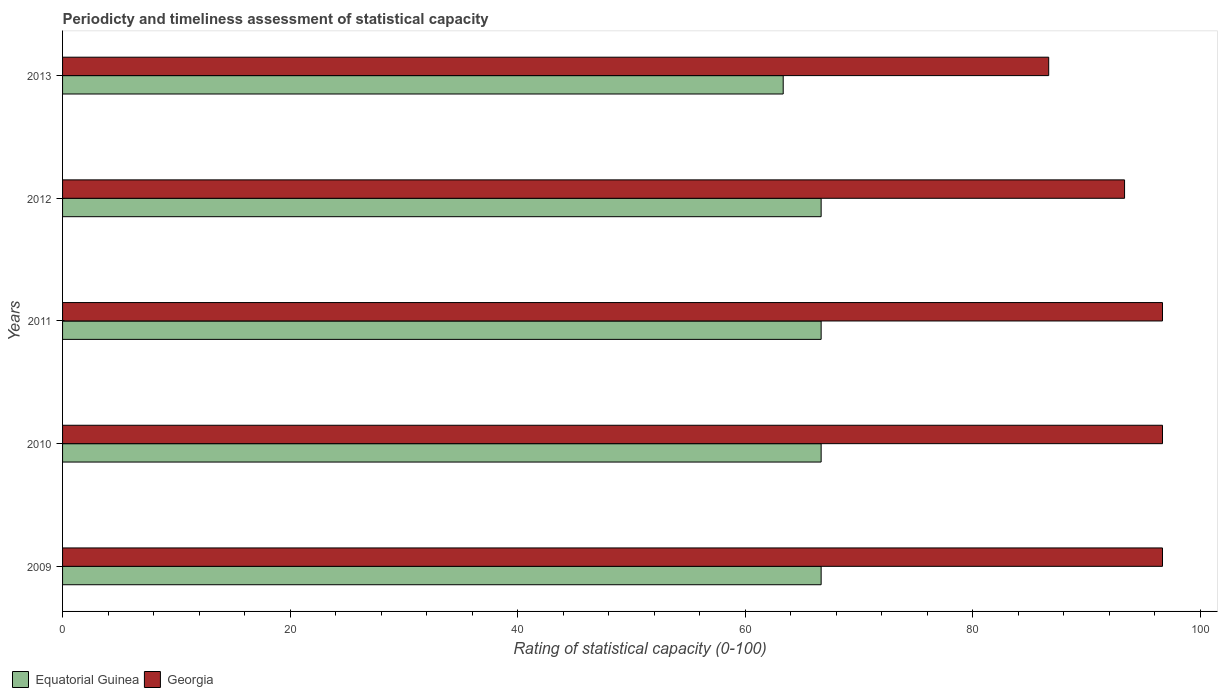Are the number of bars on each tick of the Y-axis equal?
Offer a terse response. Yes. What is the rating of statistical capacity in Georgia in 2013?
Provide a succinct answer. 86.67. Across all years, what is the maximum rating of statistical capacity in Equatorial Guinea?
Provide a short and direct response. 66.67. Across all years, what is the minimum rating of statistical capacity in Georgia?
Offer a very short reply. 86.67. In which year was the rating of statistical capacity in Equatorial Guinea maximum?
Your answer should be compact. 2009. In which year was the rating of statistical capacity in Equatorial Guinea minimum?
Your answer should be very brief. 2013. What is the total rating of statistical capacity in Equatorial Guinea in the graph?
Your answer should be compact. 330. What is the difference between the rating of statistical capacity in Equatorial Guinea in 2011 and that in 2012?
Make the answer very short. 0. What is the difference between the rating of statistical capacity in Georgia in 2010 and the rating of statistical capacity in Equatorial Guinea in 2013?
Provide a succinct answer. 33.33. What is the average rating of statistical capacity in Georgia per year?
Your answer should be very brief. 94. In the year 2013, what is the difference between the rating of statistical capacity in Equatorial Guinea and rating of statistical capacity in Georgia?
Provide a short and direct response. -23.33. In how many years, is the rating of statistical capacity in Georgia greater than 8 ?
Ensure brevity in your answer.  5. What is the ratio of the rating of statistical capacity in Georgia in 2009 to that in 2013?
Make the answer very short. 1.12. Is the rating of statistical capacity in Equatorial Guinea in 2010 less than that in 2013?
Your response must be concise. No. Is the difference between the rating of statistical capacity in Equatorial Guinea in 2011 and 2012 greater than the difference between the rating of statistical capacity in Georgia in 2011 and 2012?
Your response must be concise. No. What is the difference between the highest and the lowest rating of statistical capacity in Georgia?
Offer a terse response. 10. Is the sum of the rating of statistical capacity in Equatorial Guinea in 2010 and 2013 greater than the maximum rating of statistical capacity in Georgia across all years?
Make the answer very short. Yes. What does the 2nd bar from the top in 2013 represents?
Your answer should be very brief. Equatorial Guinea. What does the 2nd bar from the bottom in 2012 represents?
Keep it short and to the point. Georgia. How many bars are there?
Give a very brief answer. 10. How many years are there in the graph?
Your answer should be compact. 5. Does the graph contain any zero values?
Give a very brief answer. No. How many legend labels are there?
Offer a very short reply. 2. What is the title of the graph?
Offer a terse response. Periodicty and timeliness assessment of statistical capacity. Does "Least developed countries" appear as one of the legend labels in the graph?
Offer a terse response. No. What is the label or title of the X-axis?
Provide a succinct answer. Rating of statistical capacity (0-100). What is the label or title of the Y-axis?
Offer a very short reply. Years. What is the Rating of statistical capacity (0-100) of Equatorial Guinea in 2009?
Your answer should be very brief. 66.67. What is the Rating of statistical capacity (0-100) in Georgia in 2009?
Make the answer very short. 96.67. What is the Rating of statistical capacity (0-100) of Equatorial Guinea in 2010?
Give a very brief answer. 66.67. What is the Rating of statistical capacity (0-100) in Georgia in 2010?
Keep it short and to the point. 96.67. What is the Rating of statistical capacity (0-100) of Equatorial Guinea in 2011?
Your answer should be compact. 66.67. What is the Rating of statistical capacity (0-100) in Georgia in 2011?
Offer a very short reply. 96.67. What is the Rating of statistical capacity (0-100) of Equatorial Guinea in 2012?
Your answer should be very brief. 66.67. What is the Rating of statistical capacity (0-100) of Georgia in 2012?
Offer a very short reply. 93.33. What is the Rating of statistical capacity (0-100) of Equatorial Guinea in 2013?
Keep it short and to the point. 63.33. What is the Rating of statistical capacity (0-100) of Georgia in 2013?
Provide a succinct answer. 86.67. Across all years, what is the maximum Rating of statistical capacity (0-100) of Equatorial Guinea?
Make the answer very short. 66.67. Across all years, what is the maximum Rating of statistical capacity (0-100) in Georgia?
Provide a short and direct response. 96.67. Across all years, what is the minimum Rating of statistical capacity (0-100) in Equatorial Guinea?
Your answer should be compact. 63.33. Across all years, what is the minimum Rating of statistical capacity (0-100) in Georgia?
Give a very brief answer. 86.67. What is the total Rating of statistical capacity (0-100) of Equatorial Guinea in the graph?
Your answer should be compact. 330. What is the total Rating of statistical capacity (0-100) of Georgia in the graph?
Provide a succinct answer. 470. What is the difference between the Rating of statistical capacity (0-100) of Equatorial Guinea in 2009 and that in 2010?
Your answer should be compact. 0. What is the difference between the Rating of statistical capacity (0-100) of Georgia in 2009 and that in 2010?
Ensure brevity in your answer.  0. What is the difference between the Rating of statistical capacity (0-100) in Georgia in 2009 and that in 2012?
Make the answer very short. 3.33. What is the difference between the Rating of statistical capacity (0-100) in Equatorial Guinea in 2009 and that in 2013?
Your answer should be very brief. 3.33. What is the difference between the Rating of statistical capacity (0-100) in Georgia in 2009 and that in 2013?
Your answer should be very brief. 10. What is the difference between the Rating of statistical capacity (0-100) in Equatorial Guinea in 2010 and that in 2011?
Offer a terse response. 0. What is the difference between the Rating of statistical capacity (0-100) of Equatorial Guinea in 2010 and that in 2012?
Your answer should be compact. 0. What is the difference between the Rating of statistical capacity (0-100) in Georgia in 2010 and that in 2012?
Your response must be concise. 3.33. What is the difference between the Rating of statistical capacity (0-100) of Equatorial Guinea in 2010 and that in 2013?
Keep it short and to the point. 3.33. What is the difference between the Rating of statistical capacity (0-100) of Georgia in 2010 and that in 2013?
Give a very brief answer. 10. What is the difference between the Rating of statistical capacity (0-100) in Equatorial Guinea in 2011 and that in 2012?
Provide a short and direct response. 0. What is the difference between the Rating of statistical capacity (0-100) in Georgia in 2011 and that in 2012?
Provide a short and direct response. 3.33. What is the difference between the Rating of statistical capacity (0-100) in Equatorial Guinea in 2012 and that in 2013?
Ensure brevity in your answer.  3.33. What is the difference between the Rating of statistical capacity (0-100) of Equatorial Guinea in 2009 and the Rating of statistical capacity (0-100) of Georgia in 2012?
Give a very brief answer. -26.67. What is the difference between the Rating of statistical capacity (0-100) in Equatorial Guinea in 2009 and the Rating of statistical capacity (0-100) in Georgia in 2013?
Offer a terse response. -20. What is the difference between the Rating of statistical capacity (0-100) in Equatorial Guinea in 2010 and the Rating of statistical capacity (0-100) in Georgia in 2011?
Give a very brief answer. -30. What is the difference between the Rating of statistical capacity (0-100) in Equatorial Guinea in 2010 and the Rating of statistical capacity (0-100) in Georgia in 2012?
Ensure brevity in your answer.  -26.67. What is the difference between the Rating of statistical capacity (0-100) in Equatorial Guinea in 2010 and the Rating of statistical capacity (0-100) in Georgia in 2013?
Offer a very short reply. -20. What is the difference between the Rating of statistical capacity (0-100) of Equatorial Guinea in 2011 and the Rating of statistical capacity (0-100) of Georgia in 2012?
Keep it short and to the point. -26.67. What is the difference between the Rating of statistical capacity (0-100) in Equatorial Guinea in 2011 and the Rating of statistical capacity (0-100) in Georgia in 2013?
Give a very brief answer. -20. What is the average Rating of statistical capacity (0-100) of Equatorial Guinea per year?
Your response must be concise. 66. What is the average Rating of statistical capacity (0-100) of Georgia per year?
Make the answer very short. 94. In the year 2009, what is the difference between the Rating of statistical capacity (0-100) of Equatorial Guinea and Rating of statistical capacity (0-100) of Georgia?
Offer a terse response. -30. In the year 2010, what is the difference between the Rating of statistical capacity (0-100) of Equatorial Guinea and Rating of statistical capacity (0-100) of Georgia?
Give a very brief answer. -30. In the year 2012, what is the difference between the Rating of statistical capacity (0-100) of Equatorial Guinea and Rating of statistical capacity (0-100) of Georgia?
Provide a short and direct response. -26.67. In the year 2013, what is the difference between the Rating of statistical capacity (0-100) in Equatorial Guinea and Rating of statistical capacity (0-100) in Georgia?
Your answer should be very brief. -23.33. What is the ratio of the Rating of statistical capacity (0-100) in Equatorial Guinea in 2009 to that in 2010?
Your answer should be very brief. 1. What is the ratio of the Rating of statistical capacity (0-100) of Georgia in 2009 to that in 2010?
Make the answer very short. 1. What is the ratio of the Rating of statistical capacity (0-100) of Equatorial Guinea in 2009 to that in 2011?
Offer a terse response. 1. What is the ratio of the Rating of statistical capacity (0-100) of Equatorial Guinea in 2009 to that in 2012?
Ensure brevity in your answer.  1. What is the ratio of the Rating of statistical capacity (0-100) in Georgia in 2009 to that in 2012?
Offer a very short reply. 1.04. What is the ratio of the Rating of statistical capacity (0-100) of Equatorial Guinea in 2009 to that in 2013?
Your answer should be compact. 1.05. What is the ratio of the Rating of statistical capacity (0-100) of Georgia in 2009 to that in 2013?
Make the answer very short. 1.12. What is the ratio of the Rating of statistical capacity (0-100) in Equatorial Guinea in 2010 to that in 2012?
Provide a short and direct response. 1. What is the ratio of the Rating of statistical capacity (0-100) in Georgia in 2010 to that in 2012?
Your answer should be compact. 1.04. What is the ratio of the Rating of statistical capacity (0-100) of Equatorial Guinea in 2010 to that in 2013?
Your response must be concise. 1.05. What is the ratio of the Rating of statistical capacity (0-100) of Georgia in 2010 to that in 2013?
Provide a succinct answer. 1.12. What is the ratio of the Rating of statistical capacity (0-100) of Equatorial Guinea in 2011 to that in 2012?
Give a very brief answer. 1. What is the ratio of the Rating of statistical capacity (0-100) of Georgia in 2011 to that in 2012?
Your answer should be compact. 1.04. What is the ratio of the Rating of statistical capacity (0-100) in Equatorial Guinea in 2011 to that in 2013?
Offer a very short reply. 1.05. What is the ratio of the Rating of statistical capacity (0-100) of Georgia in 2011 to that in 2013?
Ensure brevity in your answer.  1.12. What is the ratio of the Rating of statistical capacity (0-100) of Equatorial Guinea in 2012 to that in 2013?
Provide a succinct answer. 1.05. What is the difference between the highest and the second highest Rating of statistical capacity (0-100) in Equatorial Guinea?
Offer a very short reply. 0. What is the difference between the highest and the second highest Rating of statistical capacity (0-100) of Georgia?
Offer a terse response. 0. What is the difference between the highest and the lowest Rating of statistical capacity (0-100) in Equatorial Guinea?
Give a very brief answer. 3.33. What is the difference between the highest and the lowest Rating of statistical capacity (0-100) of Georgia?
Give a very brief answer. 10. 